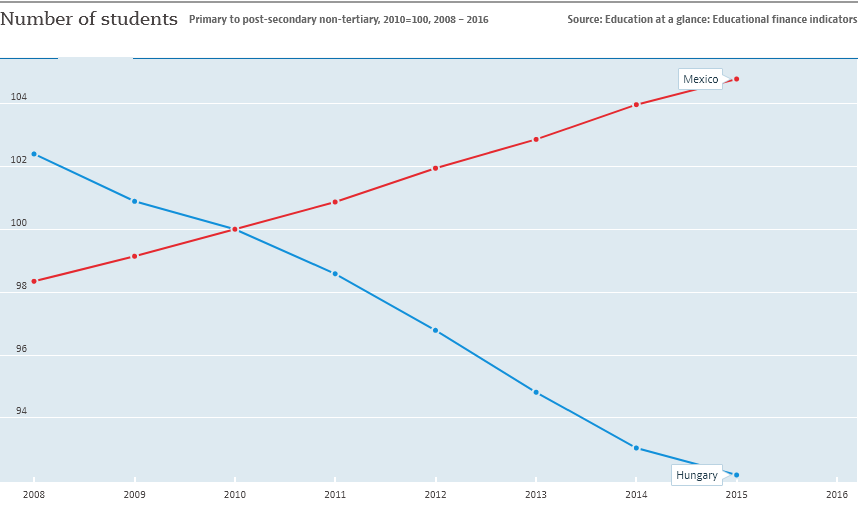Draw attention to some important aspects in this diagram. In the year 2015, the highest number of students was recorded in Mexico. The year 2008 recorded the highest number of students in Hungary. 